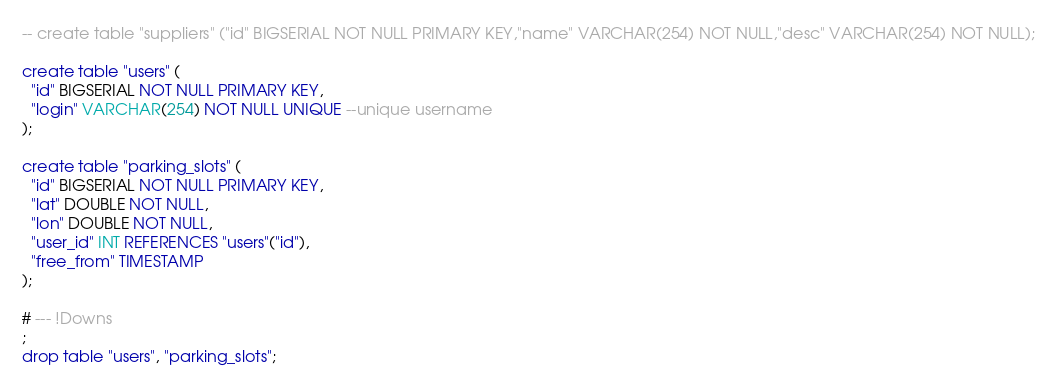Convert code to text. <code><loc_0><loc_0><loc_500><loc_500><_SQL_>-- create table "suppliers" ("id" BIGSERIAL NOT NULL PRIMARY KEY,"name" VARCHAR(254) NOT NULL,"desc" VARCHAR(254) NOT NULL);

create table "users" (
  "id" BIGSERIAL NOT NULL PRIMARY KEY,
  "login" VARCHAR(254) NOT NULL UNIQUE --unique username
);

create table "parking_slots" (
  "id" BIGSERIAL NOT NULL PRIMARY KEY,
  "lat" DOUBLE NOT NULL,
  "lon" DOUBLE NOT NULL,
  "user_id" INT REFERENCES "users"("id"),
  "free_from" TIMESTAMP
);

# --- !Downs
;
drop table "users", "parking_slots";</code> 